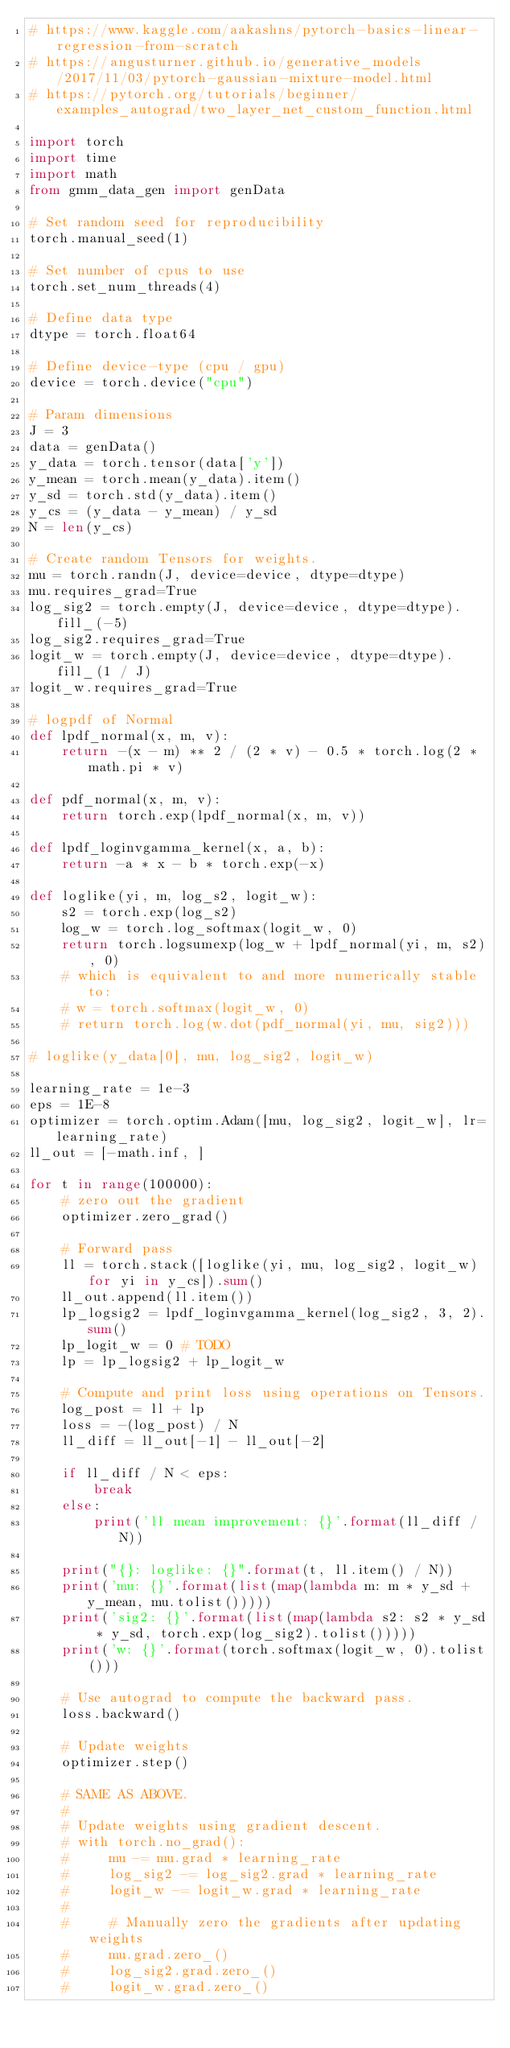Convert code to text. <code><loc_0><loc_0><loc_500><loc_500><_Python_># https://www.kaggle.com/aakashns/pytorch-basics-linear-regression-from-scratch
# https://angusturner.github.io/generative_models/2017/11/03/pytorch-gaussian-mixture-model.html
# https://pytorch.org/tutorials/beginner/examples_autograd/two_layer_net_custom_function.html

import torch
import time
import math
from gmm_data_gen import genData

# Set random seed for reproducibility
torch.manual_seed(1)

# Set number of cpus to use
torch.set_num_threads(4)

# Define data type
dtype = torch.float64

# Define device-type (cpu / gpu)
device = torch.device("cpu")

# Param dimensions
J = 3
data = genData()
y_data = torch.tensor(data['y'])
y_mean = torch.mean(y_data).item()
y_sd = torch.std(y_data).item()
y_cs = (y_data - y_mean) / y_sd
N = len(y_cs)

# Create random Tensors for weights.
mu = torch.randn(J, device=device, dtype=dtype)
mu.requires_grad=True
log_sig2 = torch.empty(J, device=device, dtype=dtype).fill_(-5)
log_sig2.requires_grad=True
logit_w = torch.empty(J, device=device, dtype=dtype).fill_(1 / J)
logit_w.requires_grad=True

# logpdf of Normal
def lpdf_normal(x, m, v):
    return -(x - m) ** 2 / (2 * v) - 0.5 * torch.log(2 * math.pi * v)

def pdf_normal(x, m, v):
    return torch.exp(lpdf_normal(x, m, v))

def lpdf_loginvgamma_kernel(x, a, b):
    return -a * x - b * torch.exp(-x)

def loglike(yi, m, log_s2, logit_w):
    s2 = torch.exp(log_s2)
    log_w = torch.log_softmax(logit_w, 0)
    return torch.logsumexp(log_w + lpdf_normal(yi, m, s2), 0)
    # which is equivalent to and more numerically stable to:
    # w = torch.softmax(logit_w, 0)
    # return torch.log(w.dot(pdf_normal(yi, mu, sig2)))

# loglike(y_data[0], mu, log_sig2, logit_w)

learning_rate = 1e-3
eps = 1E-8
optimizer = torch.optim.Adam([mu, log_sig2, logit_w], lr=learning_rate)
ll_out = [-math.inf, ]

for t in range(100000):
    # zero out the gradient
    optimizer.zero_grad()

    # Forward pass
    ll = torch.stack([loglike(yi, mu, log_sig2, logit_w) for yi in y_cs]).sum()
    ll_out.append(ll.item())
    lp_logsig2 = lpdf_loginvgamma_kernel(log_sig2, 3, 2).sum()
    lp_logit_w = 0 # TODO
    lp = lp_logsig2 + lp_logit_w

    # Compute and print loss using operations on Tensors.
    log_post = ll + lp
    loss = -(log_post) / N
    ll_diff = ll_out[-1] - ll_out[-2]

    if ll_diff / N < eps:
        break
    else:
        print('ll mean improvement: {}'.format(ll_diff / N))

    print("{}: loglike: {}".format(t, ll.item() / N))
    print('mu: {}'.format(list(map(lambda m: m * y_sd + y_mean, mu.tolist()))))
    print('sig2: {}'.format(list(map(lambda s2: s2 * y_sd * y_sd, torch.exp(log_sig2).tolist()))))
    print('w: {}'.format(torch.softmax(logit_w, 0).tolist()))

    # Use autograd to compute the backward pass. 
    loss.backward()

    # Update weights
    optimizer.step()

    # SAME AS ABOVE.
    #
    # Update weights using gradient descent.
    # with torch.no_grad():
    #     mu -= mu.grad * learning_rate
    #     log_sig2 -= log_sig2.grad * learning_rate
    #     logit_w -= logit_w.grad * learning_rate
    #
    #     # Manually zero the gradients after updating weights
    #     mu.grad.zero_()
    #     log_sig2.grad.zero_()
    #     logit_w.grad.zero_()
  

</code> 